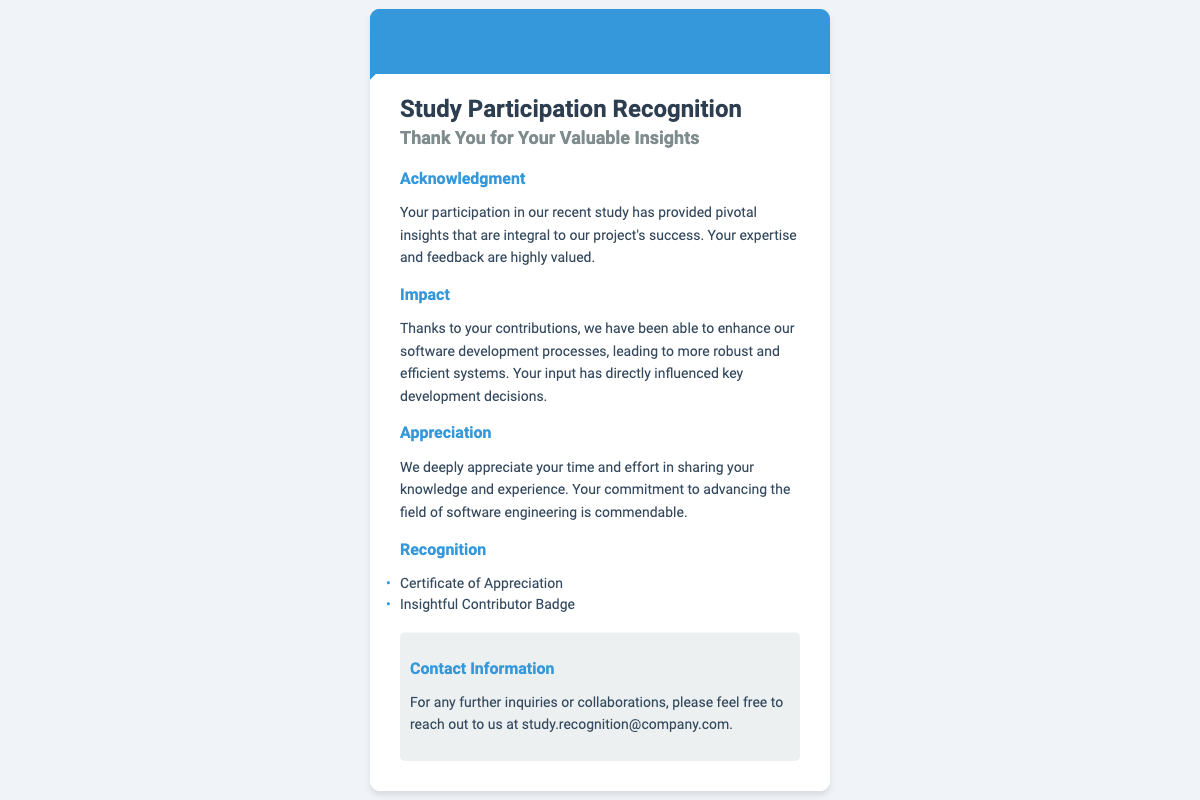What is the name of the software engineer? The document mentions the name of the software engineer at the top as "John Doe."
Answer: John Doe What is the main purpose of this document? The document is a recognition for participation in a study, specifically thanking the participant for their insights.
Answer: Study Participation Recognition What type of badge is mentioned in the recognition? The document lists an "Insightful Contributor Badge" as part of the recognition rewards.
Answer: Insightful Contributor Badge Which email address is provided for inquiries? The contact section of the document gives an email for further inquiries as "study.recognition@company.com."
Answer: study.recognition@company.com How many recognition items are listed? There are two items specified under the recognition section, which are a certificate and a badge.
Answer: Two How does the participation impact the project's success? The document states that insights from the study have led to enhancements in software development processes.
Answer: Enhancements in software development processes What is described as commendable in the appreciation section? The document appreciates the participant's commitment to advancing the field of software engineering as commendable.
Answer: Commitment to advancing the field of software engineering What kind of insights were provided by the participant? The document states that the insights provided were pivotal and integral to the project's success.
Answer: Pivotal insights 